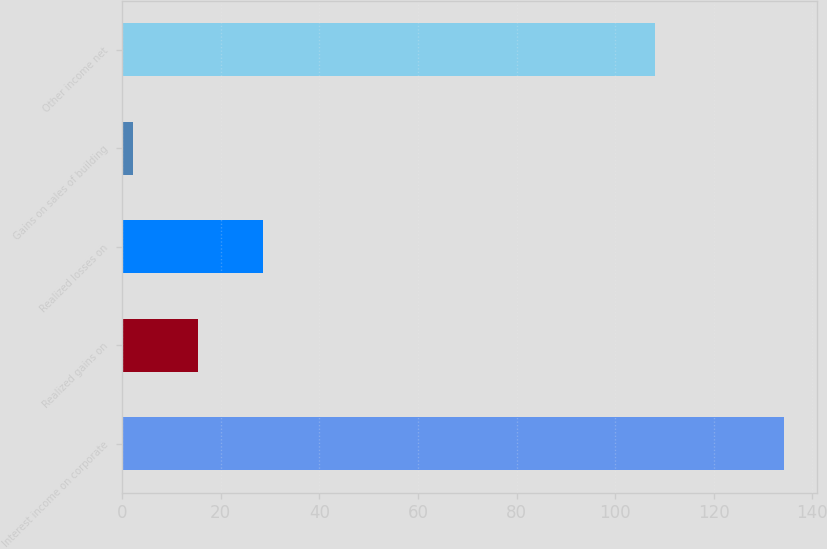Convert chart to OTSL. <chart><loc_0><loc_0><loc_500><loc_500><bar_chart><fcel>Interest income on corporate<fcel>Realized gains on<fcel>Realized losses on<fcel>Gains on sales of building<fcel>Other income net<nl><fcel>134.2<fcel>15.4<fcel>28.6<fcel>2.2<fcel>108<nl></chart> 